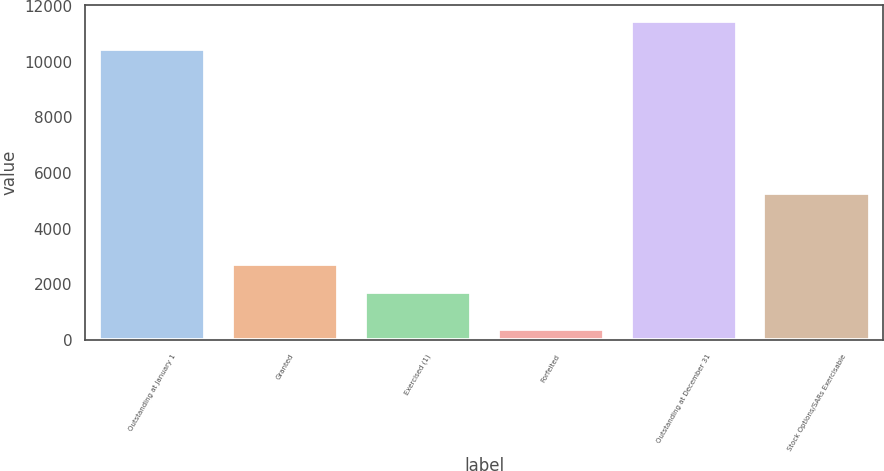Convert chart. <chart><loc_0><loc_0><loc_500><loc_500><bar_chart><fcel>Outstanding at January 1<fcel>Granted<fcel>Exercised (1)<fcel>Forfeited<fcel>Outstanding at December 31<fcel>Stock Options/SARs Exercisable<nl><fcel>10452<fcel>2728.6<fcel>1718<fcel>387<fcel>11462.6<fcel>5287<nl></chart> 